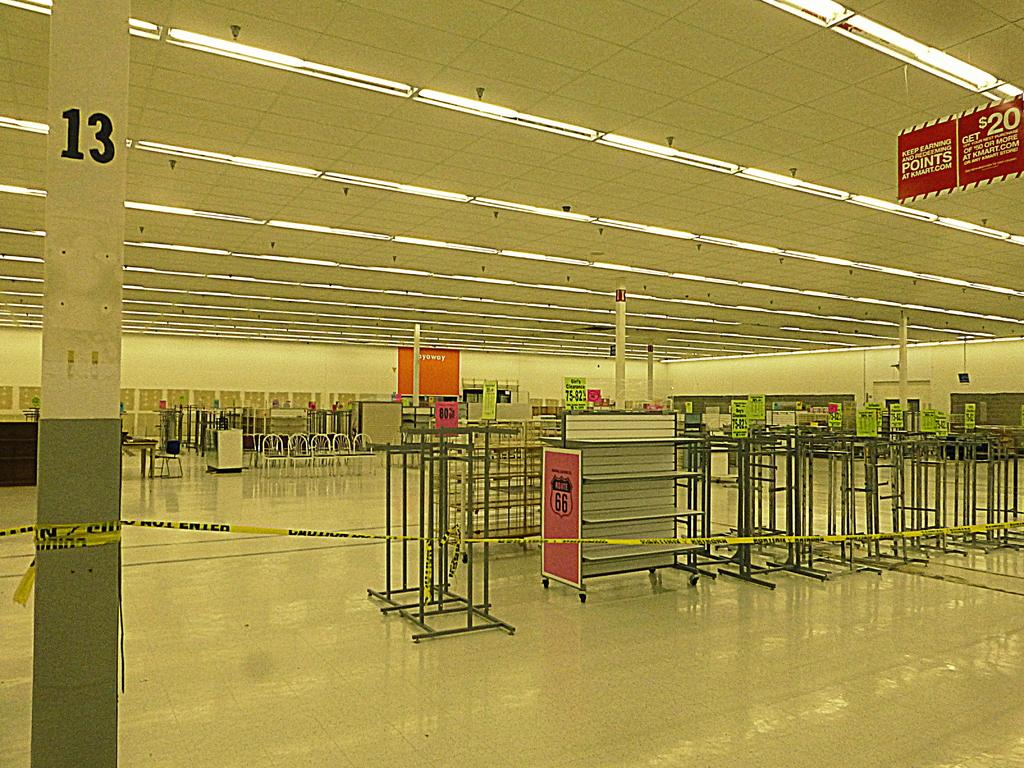Where is the setting of the image? The image is set in a hall. What can be seen in the hall? There are poles in the hall. Are there any other objects or features in the hall? Yes, there are other objects in the hall. How many pizzas are being served on the pan in the image? There is no pan or pizzas present in the image. 